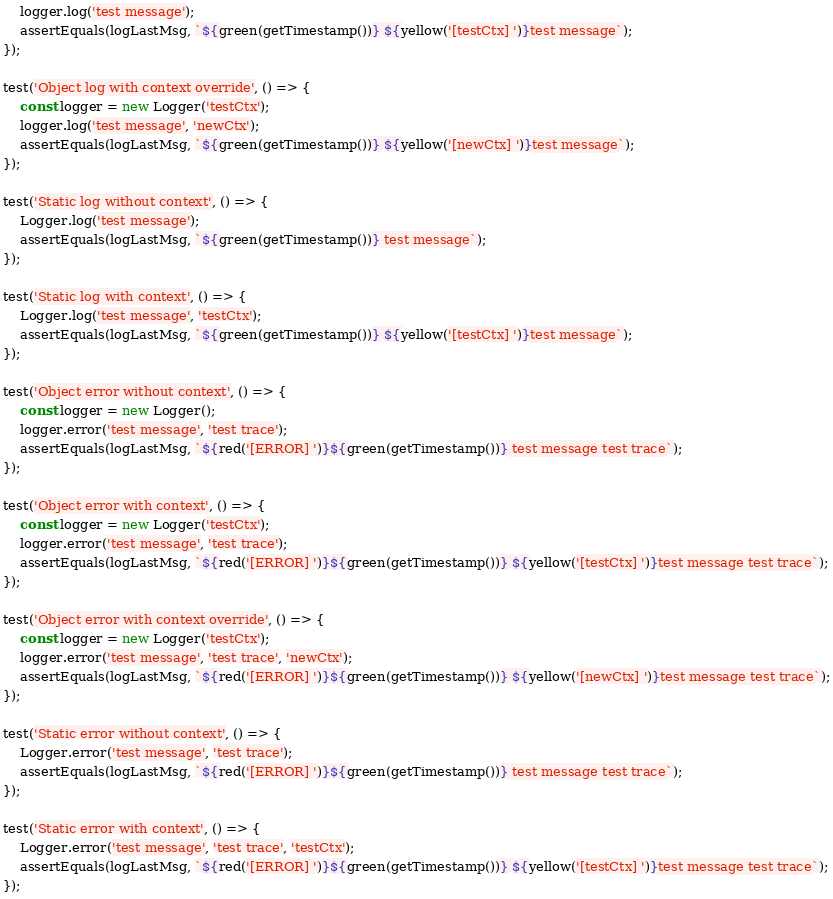Convert code to text. <code><loc_0><loc_0><loc_500><loc_500><_TypeScript_>    logger.log('test message');
    assertEquals(logLastMsg, `${green(getTimestamp())} ${yellow('[testCtx] ')}test message`);
});

test('Object log with context override', () => {
    const logger = new Logger('testCtx');
    logger.log('test message', 'newCtx');
    assertEquals(logLastMsg, `${green(getTimestamp())} ${yellow('[newCtx] ')}test message`);
});

test('Static log without context', () => {
    Logger.log('test message');
    assertEquals(logLastMsg, `${green(getTimestamp())} test message`);
});

test('Static log with context', () => {
    Logger.log('test message', 'testCtx');
    assertEquals(logLastMsg, `${green(getTimestamp())} ${yellow('[testCtx] ')}test message`);
});

test('Object error without context', () => {
    const logger = new Logger();
    logger.error('test message', 'test trace');
    assertEquals(logLastMsg, `${red('[ERROR] ')}${green(getTimestamp())} test message test trace`);
});

test('Object error with context', () => {
    const logger = new Logger('testCtx');
    logger.error('test message', 'test trace');
    assertEquals(logLastMsg, `${red('[ERROR] ')}${green(getTimestamp())} ${yellow('[testCtx] ')}test message test trace`);
});

test('Object error with context override', () => {
    const logger = new Logger('testCtx');
    logger.error('test message', 'test trace', 'newCtx');
    assertEquals(logLastMsg, `${red('[ERROR] ')}${green(getTimestamp())} ${yellow('[newCtx] ')}test message test trace`);
});

test('Static error without context', () => {
    Logger.error('test message', 'test trace');
    assertEquals(logLastMsg, `${red('[ERROR] ')}${green(getTimestamp())} test message test trace`);
});

test('Static error with context', () => {
    Logger.error('test message', 'test trace', 'testCtx');
    assertEquals(logLastMsg, `${red('[ERROR] ')}${green(getTimestamp())} ${yellow('[testCtx] ')}test message test trace`);
});
</code> 